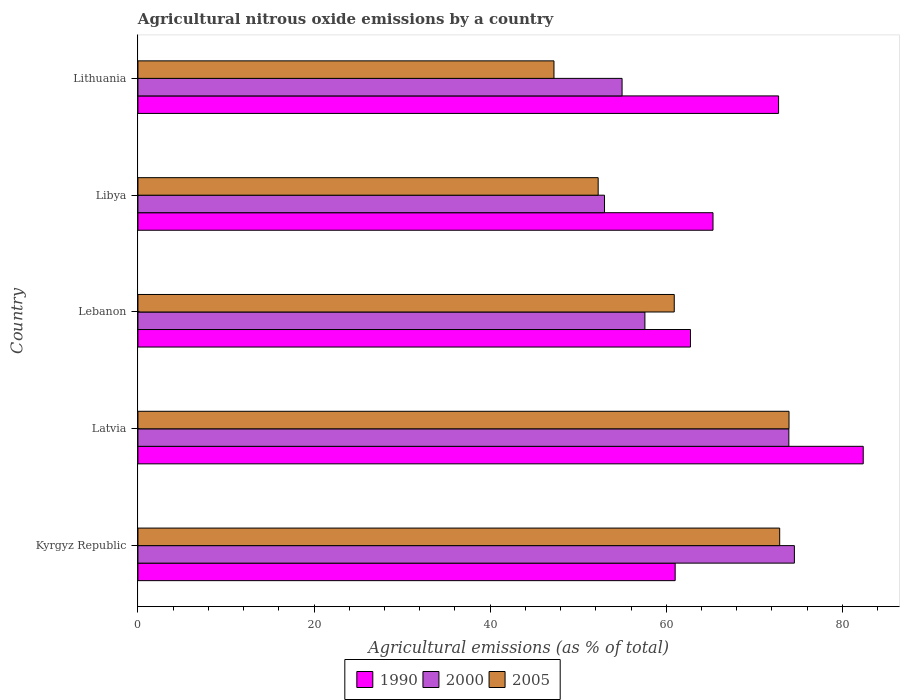How many different coloured bars are there?
Provide a succinct answer. 3. How many groups of bars are there?
Offer a terse response. 5. Are the number of bars on each tick of the Y-axis equal?
Ensure brevity in your answer.  Yes. How many bars are there on the 2nd tick from the top?
Offer a terse response. 3. What is the label of the 5th group of bars from the top?
Your answer should be very brief. Kyrgyz Republic. In how many cases, is the number of bars for a given country not equal to the number of legend labels?
Offer a terse response. 0. What is the amount of agricultural nitrous oxide emitted in 1990 in Libya?
Keep it short and to the point. 65.31. Across all countries, what is the maximum amount of agricultural nitrous oxide emitted in 1990?
Give a very brief answer. 82.37. Across all countries, what is the minimum amount of agricultural nitrous oxide emitted in 2000?
Your answer should be compact. 52.99. In which country was the amount of agricultural nitrous oxide emitted in 2005 maximum?
Ensure brevity in your answer.  Latvia. In which country was the amount of agricultural nitrous oxide emitted in 1990 minimum?
Offer a terse response. Kyrgyz Republic. What is the total amount of agricultural nitrous oxide emitted in 1990 in the graph?
Give a very brief answer. 344.21. What is the difference between the amount of agricultural nitrous oxide emitted in 2005 in Lebanon and that in Libya?
Your answer should be compact. 8.64. What is the difference between the amount of agricultural nitrous oxide emitted in 2005 in Kyrgyz Republic and the amount of agricultural nitrous oxide emitted in 2000 in Latvia?
Make the answer very short. -1.04. What is the average amount of agricultural nitrous oxide emitted in 1990 per country?
Your answer should be compact. 68.84. What is the difference between the amount of agricultural nitrous oxide emitted in 1990 and amount of agricultural nitrous oxide emitted in 2005 in Libya?
Offer a terse response. 13.04. In how many countries, is the amount of agricultural nitrous oxide emitted in 1990 greater than 36 %?
Provide a succinct answer. 5. What is the ratio of the amount of agricultural nitrous oxide emitted in 1990 in Libya to that in Lithuania?
Offer a very short reply. 0.9. Is the amount of agricultural nitrous oxide emitted in 2005 in Kyrgyz Republic less than that in Libya?
Keep it short and to the point. No. Is the difference between the amount of agricultural nitrous oxide emitted in 1990 in Lebanon and Lithuania greater than the difference between the amount of agricultural nitrous oxide emitted in 2005 in Lebanon and Lithuania?
Offer a terse response. No. What is the difference between the highest and the second highest amount of agricultural nitrous oxide emitted in 2005?
Give a very brief answer. 1.06. What is the difference between the highest and the lowest amount of agricultural nitrous oxide emitted in 2005?
Provide a short and direct response. 26.7. Is the sum of the amount of agricultural nitrous oxide emitted in 2000 in Kyrgyz Republic and Latvia greater than the maximum amount of agricultural nitrous oxide emitted in 1990 across all countries?
Make the answer very short. Yes. What does the 1st bar from the top in Latvia represents?
Your answer should be compact. 2005. What does the 3rd bar from the bottom in Lithuania represents?
Ensure brevity in your answer.  2005. Are all the bars in the graph horizontal?
Keep it short and to the point. Yes. What is the difference between two consecutive major ticks on the X-axis?
Offer a very short reply. 20. Are the values on the major ticks of X-axis written in scientific E-notation?
Offer a very short reply. No. Does the graph contain any zero values?
Ensure brevity in your answer.  No. Does the graph contain grids?
Make the answer very short. No. How are the legend labels stacked?
Your answer should be compact. Horizontal. What is the title of the graph?
Keep it short and to the point. Agricultural nitrous oxide emissions by a country. Does "2012" appear as one of the legend labels in the graph?
Offer a terse response. No. What is the label or title of the X-axis?
Keep it short and to the point. Agricultural emissions (as % of total). What is the label or title of the Y-axis?
Offer a very short reply. Country. What is the Agricultural emissions (as % of total) of 1990 in Kyrgyz Republic?
Provide a succinct answer. 61.01. What is the Agricultural emissions (as % of total) in 2000 in Kyrgyz Republic?
Keep it short and to the point. 74.56. What is the Agricultural emissions (as % of total) of 2005 in Kyrgyz Republic?
Make the answer very short. 72.88. What is the Agricultural emissions (as % of total) in 1990 in Latvia?
Give a very brief answer. 82.37. What is the Agricultural emissions (as % of total) of 2000 in Latvia?
Offer a terse response. 73.93. What is the Agricultural emissions (as % of total) of 2005 in Latvia?
Offer a terse response. 73.94. What is the Agricultural emissions (as % of total) of 1990 in Lebanon?
Provide a short and direct response. 62.76. What is the Agricultural emissions (as % of total) of 2000 in Lebanon?
Keep it short and to the point. 57.58. What is the Agricultural emissions (as % of total) of 2005 in Lebanon?
Ensure brevity in your answer.  60.91. What is the Agricultural emissions (as % of total) of 1990 in Libya?
Give a very brief answer. 65.31. What is the Agricultural emissions (as % of total) of 2000 in Libya?
Offer a very short reply. 52.99. What is the Agricultural emissions (as % of total) in 2005 in Libya?
Make the answer very short. 52.27. What is the Agricultural emissions (as % of total) in 1990 in Lithuania?
Offer a very short reply. 72.76. What is the Agricultural emissions (as % of total) in 2000 in Lithuania?
Give a very brief answer. 54.98. What is the Agricultural emissions (as % of total) of 2005 in Lithuania?
Offer a terse response. 47.25. Across all countries, what is the maximum Agricultural emissions (as % of total) of 1990?
Make the answer very short. 82.37. Across all countries, what is the maximum Agricultural emissions (as % of total) of 2000?
Your answer should be very brief. 74.56. Across all countries, what is the maximum Agricultural emissions (as % of total) in 2005?
Ensure brevity in your answer.  73.94. Across all countries, what is the minimum Agricultural emissions (as % of total) of 1990?
Your answer should be compact. 61.01. Across all countries, what is the minimum Agricultural emissions (as % of total) of 2000?
Give a very brief answer. 52.99. Across all countries, what is the minimum Agricultural emissions (as % of total) in 2005?
Provide a succinct answer. 47.25. What is the total Agricultural emissions (as % of total) of 1990 in the graph?
Your response must be concise. 344.21. What is the total Agricultural emissions (as % of total) of 2000 in the graph?
Give a very brief answer. 314.03. What is the total Agricultural emissions (as % of total) in 2005 in the graph?
Your response must be concise. 307.26. What is the difference between the Agricultural emissions (as % of total) in 1990 in Kyrgyz Republic and that in Latvia?
Keep it short and to the point. -21.36. What is the difference between the Agricultural emissions (as % of total) in 2000 in Kyrgyz Republic and that in Latvia?
Make the answer very short. 0.63. What is the difference between the Agricultural emissions (as % of total) in 2005 in Kyrgyz Republic and that in Latvia?
Your answer should be very brief. -1.06. What is the difference between the Agricultural emissions (as % of total) in 1990 in Kyrgyz Republic and that in Lebanon?
Give a very brief answer. -1.74. What is the difference between the Agricultural emissions (as % of total) of 2000 in Kyrgyz Republic and that in Lebanon?
Keep it short and to the point. 16.98. What is the difference between the Agricultural emissions (as % of total) of 2005 in Kyrgyz Republic and that in Lebanon?
Provide a succinct answer. 11.97. What is the difference between the Agricultural emissions (as % of total) of 1990 in Kyrgyz Republic and that in Libya?
Make the answer very short. -4.3. What is the difference between the Agricultural emissions (as % of total) of 2000 in Kyrgyz Republic and that in Libya?
Offer a terse response. 21.57. What is the difference between the Agricultural emissions (as % of total) of 2005 in Kyrgyz Republic and that in Libya?
Ensure brevity in your answer.  20.61. What is the difference between the Agricultural emissions (as % of total) of 1990 in Kyrgyz Republic and that in Lithuania?
Give a very brief answer. -11.74. What is the difference between the Agricultural emissions (as % of total) in 2000 in Kyrgyz Republic and that in Lithuania?
Your answer should be compact. 19.57. What is the difference between the Agricultural emissions (as % of total) of 2005 in Kyrgyz Republic and that in Lithuania?
Your answer should be very brief. 25.64. What is the difference between the Agricultural emissions (as % of total) of 1990 in Latvia and that in Lebanon?
Give a very brief answer. 19.62. What is the difference between the Agricultural emissions (as % of total) in 2000 in Latvia and that in Lebanon?
Provide a succinct answer. 16.35. What is the difference between the Agricultural emissions (as % of total) of 2005 in Latvia and that in Lebanon?
Give a very brief answer. 13.03. What is the difference between the Agricultural emissions (as % of total) of 1990 in Latvia and that in Libya?
Your answer should be compact. 17.06. What is the difference between the Agricultural emissions (as % of total) in 2000 in Latvia and that in Libya?
Give a very brief answer. 20.94. What is the difference between the Agricultural emissions (as % of total) in 2005 in Latvia and that in Libya?
Provide a succinct answer. 21.67. What is the difference between the Agricultural emissions (as % of total) in 1990 in Latvia and that in Lithuania?
Offer a very short reply. 9.62. What is the difference between the Agricultural emissions (as % of total) in 2000 in Latvia and that in Lithuania?
Keep it short and to the point. 18.94. What is the difference between the Agricultural emissions (as % of total) of 2005 in Latvia and that in Lithuania?
Offer a very short reply. 26.7. What is the difference between the Agricultural emissions (as % of total) of 1990 in Lebanon and that in Libya?
Ensure brevity in your answer.  -2.56. What is the difference between the Agricultural emissions (as % of total) in 2000 in Lebanon and that in Libya?
Give a very brief answer. 4.59. What is the difference between the Agricultural emissions (as % of total) in 2005 in Lebanon and that in Libya?
Give a very brief answer. 8.64. What is the difference between the Agricultural emissions (as % of total) in 1990 in Lebanon and that in Lithuania?
Your answer should be very brief. -10. What is the difference between the Agricultural emissions (as % of total) in 2000 in Lebanon and that in Lithuania?
Provide a short and direct response. 2.59. What is the difference between the Agricultural emissions (as % of total) in 2005 in Lebanon and that in Lithuania?
Provide a short and direct response. 13.66. What is the difference between the Agricultural emissions (as % of total) in 1990 in Libya and that in Lithuania?
Your answer should be very brief. -7.45. What is the difference between the Agricultural emissions (as % of total) of 2000 in Libya and that in Lithuania?
Provide a succinct answer. -2. What is the difference between the Agricultural emissions (as % of total) in 2005 in Libya and that in Lithuania?
Provide a succinct answer. 5.02. What is the difference between the Agricultural emissions (as % of total) of 1990 in Kyrgyz Republic and the Agricultural emissions (as % of total) of 2000 in Latvia?
Give a very brief answer. -12.91. What is the difference between the Agricultural emissions (as % of total) in 1990 in Kyrgyz Republic and the Agricultural emissions (as % of total) in 2005 in Latvia?
Keep it short and to the point. -12.93. What is the difference between the Agricultural emissions (as % of total) in 2000 in Kyrgyz Republic and the Agricultural emissions (as % of total) in 2005 in Latvia?
Ensure brevity in your answer.  0.61. What is the difference between the Agricultural emissions (as % of total) in 1990 in Kyrgyz Republic and the Agricultural emissions (as % of total) in 2000 in Lebanon?
Your response must be concise. 3.44. What is the difference between the Agricultural emissions (as % of total) of 1990 in Kyrgyz Republic and the Agricultural emissions (as % of total) of 2005 in Lebanon?
Offer a very short reply. 0.1. What is the difference between the Agricultural emissions (as % of total) in 2000 in Kyrgyz Republic and the Agricultural emissions (as % of total) in 2005 in Lebanon?
Offer a terse response. 13.65. What is the difference between the Agricultural emissions (as % of total) of 1990 in Kyrgyz Republic and the Agricultural emissions (as % of total) of 2000 in Libya?
Your answer should be compact. 8.03. What is the difference between the Agricultural emissions (as % of total) of 1990 in Kyrgyz Republic and the Agricultural emissions (as % of total) of 2005 in Libya?
Provide a succinct answer. 8.75. What is the difference between the Agricultural emissions (as % of total) of 2000 in Kyrgyz Republic and the Agricultural emissions (as % of total) of 2005 in Libya?
Provide a succinct answer. 22.29. What is the difference between the Agricultural emissions (as % of total) of 1990 in Kyrgyz Republic and the Agricultural emissions (as % of total) of 2000 in Lithuania?
Ensure brevity in your answer.  6.03. What is the difference between the Agricultural emissions (as % of total) in 1990 in Kyrgyz Republic and the Agricultural emissions (as % of total) in 2005 in Lithuania?
Provide a short and direct response. 13.77. What is the difference between the Agricultural emissions (as % of total) in 2000 in Kyrgyz Republic and the Agricultural emissions (as % of total) in 2005 in Lithuania?
Provide a succinct answer. 27.31. What is the difference between the Agricultural emissions (as % of total) of 1990 in Latvia and the Agricultural emissions (as % of total) of 2000 in Lebanon?
Ensure brevity in your answer.  24.8. What is the difference between the Agricultural emissions (as % of total) in 1990 in Latvia and the Agricultural emissions (as % of total) in 2005 in Lebanon?
Your answer should be compact. 21.46. What is the difference between the Agricultural emissions (as % of total) of 2000 in Latvia and the Agricultural emissions (as % of total) of 2005 in Lebanon?
Offer a very short reply. 13.02. What is the difference between the Agricultural emissions (as % of total) of 1990 in Latvia and the Agricultural emissions (as % of total) of 2000 in Libya?
Your answer should be very brief. 29.38. What is the difference between the Agricultural emissions (as % of total) in 1990 in Latvia and the Agricultural emissions (as % of total) in 2005 in Libya?
Offer a terse response. 30.1. What is the difference between the Agricultural emissions (as % of total) of 2000 in Latvia and the Agricultural emissions (as % of total) of 2005 in Libya?
Your answer should be compact. 21.66. What is the difference between the Agricultural emissions (as % of total) in 1990 in Latvia and the Agricultural emissions (as % of total) in 2000 in Lithuania?
Provide a short and direct response. 27.39. What is the difference between the Agricultural emissions (as % of total) in 1990 in Latvia and the Agricultural emissions (as % of total) in 2005 in Lithuania?
Give a very brief answer. 35.12. What is the difference between the Agricultural emissions (as % of total) of 2000 in Latvia and the Agricultural emissions (as % of total) of 2005 in Lithuania?
Provide a succinct answer. 26.68. What is the difference between the Agricultural emissions (as % of total) of 1990 in Lebanon and the Agricultural emissions (as % of total) of 2000 in Libya?
Give a very brief answer. 9.77. What is the difference between the Agricultural emissions (as % of total) of 1990 in Lebanon and the Agricultural emissions (as % of total) of 2005 in Libya?
Your answer should be very brief. 10.49. What is the difference between the Agricultural emissions (as % of total) of 2000 in Lebanon and the Agricultural emissions (as % of total) of 2005 in Libya?
Provide a short and direct response. 5.31. What is the difference between the Agricultural emissions (as % of total) in 1990 in Lebanon and the Agricultural emissions (as % of total) in 2000 in Lithuania?
Offer a terse response. 7.77. What is the difference between the Agricultural emissions (as % of total) of 1990 in Lebanon and the Agricultural emissions (as % of total) of 2005 in Lithuania?
Offer a terse response. 15.51. What is the difference between the Agricultural emissions (as % of total) in 2000 in Lebanon and the Agricultural emissions (as % of total) in 2005 in Lithuania?
Offer a very short reply. 10.33. What is the difference between the Agricultural emissions (as % of total) of 1990 in Libya and the Agricultural emissions (as % of total) of 2000 in Lithuania?
Keep it short and to the point. 10.33. What is the difference between the Agricultural emissions (as % of total) of 1990 in Libya and the Agricultural emissions (as % of total) of 2005 in Lithuania?
Offer a terse response. 18.06. What is the difference between the Agricultural emissions (as % of total) in 2000 in Libya and the Agricultural emissions (as % of total) in 2005 in Lithuania?
Offer a very short reply. 5.74. What is the average Agricultural emissions (as % of total) of 1990 per country?
Your answer should be compact. 68.84. What is the average Agricultural emissions (as % of total) of 2000 per country?
Your answer should be compact. 62.81. What is the average Agricultural emissions (as % of total) of 2005 per country?
Your answer should be compact. 61.45. What is the difference between the Agricultural emissions (as % of total) of 1990 and Agricultural emissions (as % of total) of 2000 in Kyrgyz Republic?
Your answer should be very brief. -13.54. What is the difference between the Agricultural emissions (as % of total) of 1990 and Agricultural emissions (as % of total) of 2005 in Kyrgyz Republic?
Give a very brief answer. -11.87. What is the difference between the Agricultural emissions (as % of total) of 2000 and Agricultural emissions (as % of total) of 2005 in Kyrgyz Republic?
Provide a short and direct response. 1.67. What is the difference between the Agricultural emissions (as % of total) in 1990 and Agricultural emissions (as % of total) in 2000 in Latvia?
Offer a terse response. 8.45. What is the difference between the Agricultural emissions (as % of total) of 1990 and Agricultural emissions (as % of total) of 2005 in Latvia?
Offer a terse response. 8.43. What is the difference between the Agricultural emissions (as % of total) of 2000 and Agricultural emissions (as % of total) of 2005 in Latvia?
Ensure brevity in your answer.  -0.02. What is the difference between the Agricultural emissions (as % of total) of 1990 and Agricultural emissions (as % of total) of 2000 in Lebanon?
Your response must be concise. 5.18. What is the difference between the Agricultural emissions (as % of total) in 1990 and Agricultural emissions (as % of total) in 2005 in Lebanon?
Provide a succinct answer. 1.85. What is the difference between the Agricultural emissions (as % of total) of 2000 and Agricultural emissions (as % of total) of 2005 in Lebanon?
Give a very brief answer. -3.33. What is the difference between the Agricultural emissions (as % of total) in 1990 and Agricultural emissions (as % of total) in 2000 in Libya?
Your response must be concise. 12.32. What is the difference between the Agricultural emissions (as % of total) of 1990 and Agricultural emissions (as % of total) of 2005 in Libya?
Give a very brief answer. 13.04. What is the difference between the Agricultural emissions (as % of total) of 2000 and Agricultural emissions (as % of total) of 2005 in Libya?
Give a very brief answer. 0.72. What is the difference between the Agricultural emissions (as % of total) of 1990 and Agricultural emissions (as % of total) of 2000 in Lithuania?
Your answer should be very brief. 17.77. What is the difference between the Agricultural emissions (as % of total) of 1990 and Agricultural emissions (as % of total) of 2005 in Lithuania?
Keep it short and to the point. 25.51. What is the difference between the Agricultural emissions (as % of total) in 2000 and Agricultural emissions (as % of total) in 2005 in Lithuania?
Make the answer very short. 7.74. What is the ratio of the Agricultural emissions (as % of total) of 1990 in Kyrgyz Republic to that in Latvia?
Your answer should be compact. 0.74. What is the ratio of the Agricultural emissions (as % of total) of 2000 in Kyrgyz Republic to that in Latvia?
Your answer should be compact. 1.01. What is the ratio of the Agricultural emissions (as % of total) of 2005 in Kyrgyz Republic to that in Latvia?
Keep it short and to the point. 0.99. What is the ratio of the Agricultural emissions (as % of total) in 1990 in Kyrgyz Republic to that in Lebanon?
Provide a short and direct response. 0.97. What is the ratio of the Agricultural emissions (as % of total) in 2000 in Kyrgyz Republic to that in Lebanon?
Provide a short and direct response. 1.29. What is the ratio of the Agricultural emissions (as % of total) of 2005 in Kyrgyz Republic to that in Lebanon?
Make the answer very short. 1.2. What is the ratio of the Agricultural emissions (as % of total) in 1990 in Kyrgyz Republic to that in Libya?
Give a very brief answer. 0.93. What is the ratio of the Agricultural emissions (as % of total) of 2000 in Kyrgyz Republic to that in Libya?
Offer a terse response. 1.41. What is the ratio of the Agricultural emissions (as % of total) of 2005 in Kyrgyz Republic to that in Libya?
Provide a succinct answer. 1.39. What is the ratio of the Agricultural emissions (as % of total) of 1990 in Kyrgyz Republic to that in Lithuania?
Provide a short and direct response. 0.84. What is the ratio of the Agricultural emissions (as % of total) of 2000 in Kyrgyz Republic to that in Lithuania?
Provide a succinct answer. 1.36. What is the ratio of the Agricultural emissions (as % of total) in 2005 in Kyrgyz Republic to that in Lithuania?
Provide a short and direct response. 1.54. What is the ratio of the Agricultural emissions (as % of total) of 1990 in Latvia to that in Lebanon?
Make the answer very short. 1.31. What is the ratio of the Agricultural emissions (as % of total) of 2000 in Latvia to that in Lebanon?
Your answer should be very brief. 1.28. What is the ratio of the Agricultural emissions (as % of total) in 2005 in Latvia to that in Lebanon?
Your answer should be very brief. 1.21. What is the ratio of the Agricultural emissions (as % of total) of 1990 in Latvia to that in Libya?
Keep it short and to the point. 1.26. What is the ratio of the Agricultural emissions (as % of total) of 2000 in Latvia to that in Libya?
Give a very brief answer. 1.4. What is the ratio of the Agricultural emissions (as % of total) of 2005 in Latvia to that in Libya?
Your answer should be very brief. 1.41. What is the ratio of the Agricultural emissions (as % of total) in 1990 in Latvia to that in Lithuania?
Provide a succinct answer. 1.13. What is the ratio of the Agricultural emissions (as % of total) in 2000 in Latvia to that in Lithuania?
Offer a very short reply. 1.34. What is the ratio of the Agricultural emissions (as % of total) in 2005 in Latvia to that in Lithuania?
Your response must be concise. 1.56. What is the ratio of the Agricultural emissions (as % of total) in 1990 in Lebanon to that in Libya?
Offer a very short reply. 0.96. What is the ratio of the Agricultural emissions (as % of total) in 2000 in Lebanon to that in Libya?
Provide a short and direct response. 1.09. What is the ratio of the Agricultural emissions (as % of total) in 2005 in Lebanon to that in Libya?
Your response must be concise. 1.17. What is the ratio of the Agricultural emissions (as % of total) in 1990 in Lebanon to that in Lithuania?
Your answer should be very brief. 0.86. What is the ratio of the Agricultural emissions (as % of total) in 2000 in Lebanon to that in Lithuania?
Give a very brief answer. 1.05. What is the ratio of the Agricultural emissions (as % of total) of 2005 in Lebanon to that in Lithuania?
Ensure brevity in your answer.  1.29. What is the ratio of the Agricultural emissions (as % of total) of 1990 in Libya to that in Lithuania?
Offer a terse response. 0.9. What is the ratio of the Agricultural emissions (as % of total) of 2000 in Libya to that in Lithuania?
Keep it short and to the point. 0.96. What is the ratio of the Agricultural emissions (as % of total) of 2005 in Libya to that in Lithuania?
Make the answer very short. 1.11. What is the difference between the highest and the second highest Agricultural emissions (as % of total) of 1990?
Provide a succinct answer. 9.62. What is the difference between the highest and the second highest Agricultural emissions (as % of total) of 2000?
Offer a terse response. 0.63. What is the difference between the highest and the second highest Agricultural emissions (as % of total) of 2005?
Provide a short and direct response. 1.06. What is the difference between the highest and the lowest Agricultural emissions (as % of total) of 1990?
Ensure brevity in your answer.  21.36. What is the difference between the highest and the lowest Agricultural emissions (as % of total) in 2000?
Your answer should be compact. 21.57. What is the difference between the highest and the lowest Agricultural emissions (as % of total) in 2005?
Your answer should be compact. 26.7. 